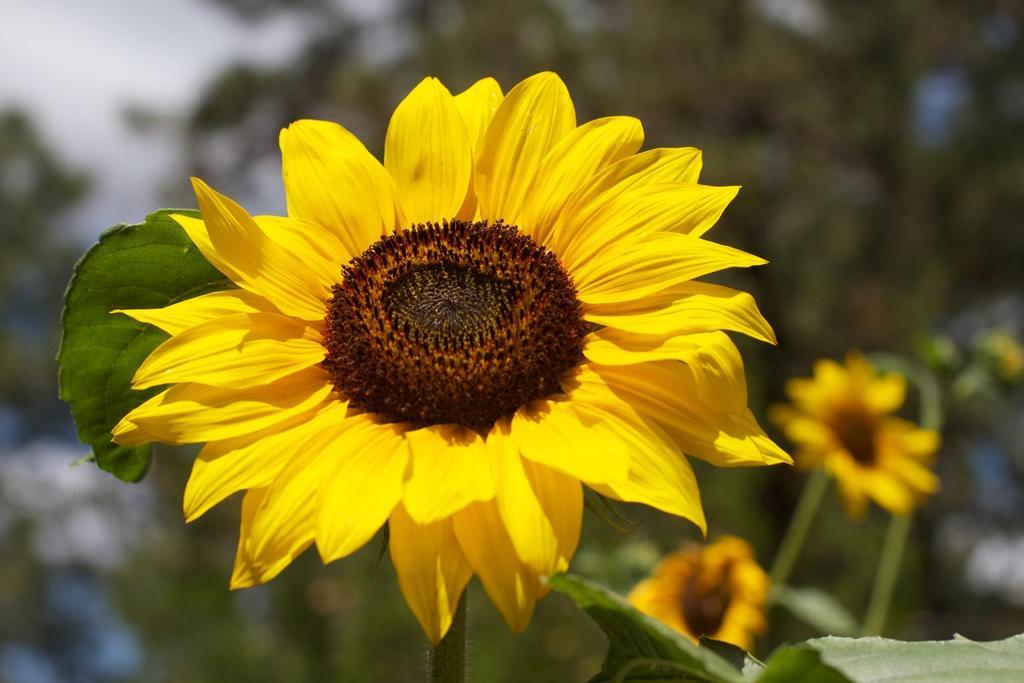Could you give a brief overview of what you see in this image? In this image, in the middle, we can see sunflower which is in yellow color. In the right corner, we can see leaves. On the right side, we can also see two flowers. In the background, we can see some trees and white color. 